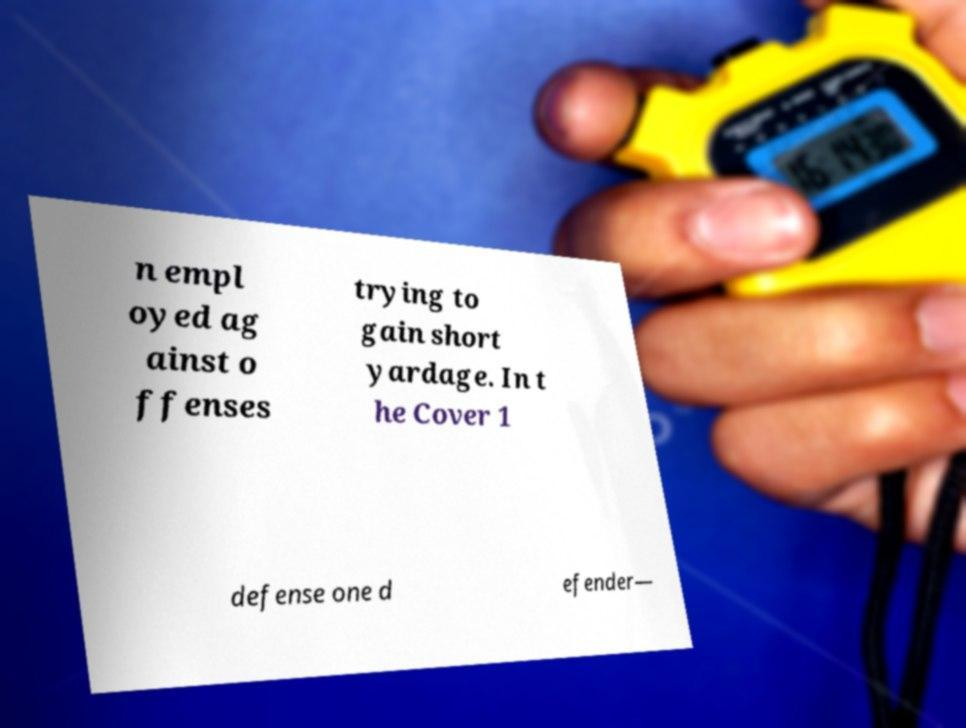Could you assist in decoding the text presented in this image and type it out clearly? n empl oyed ag ainst o ffenses trying to gain short yardage. In t he Cover 1 defense one d efender— 